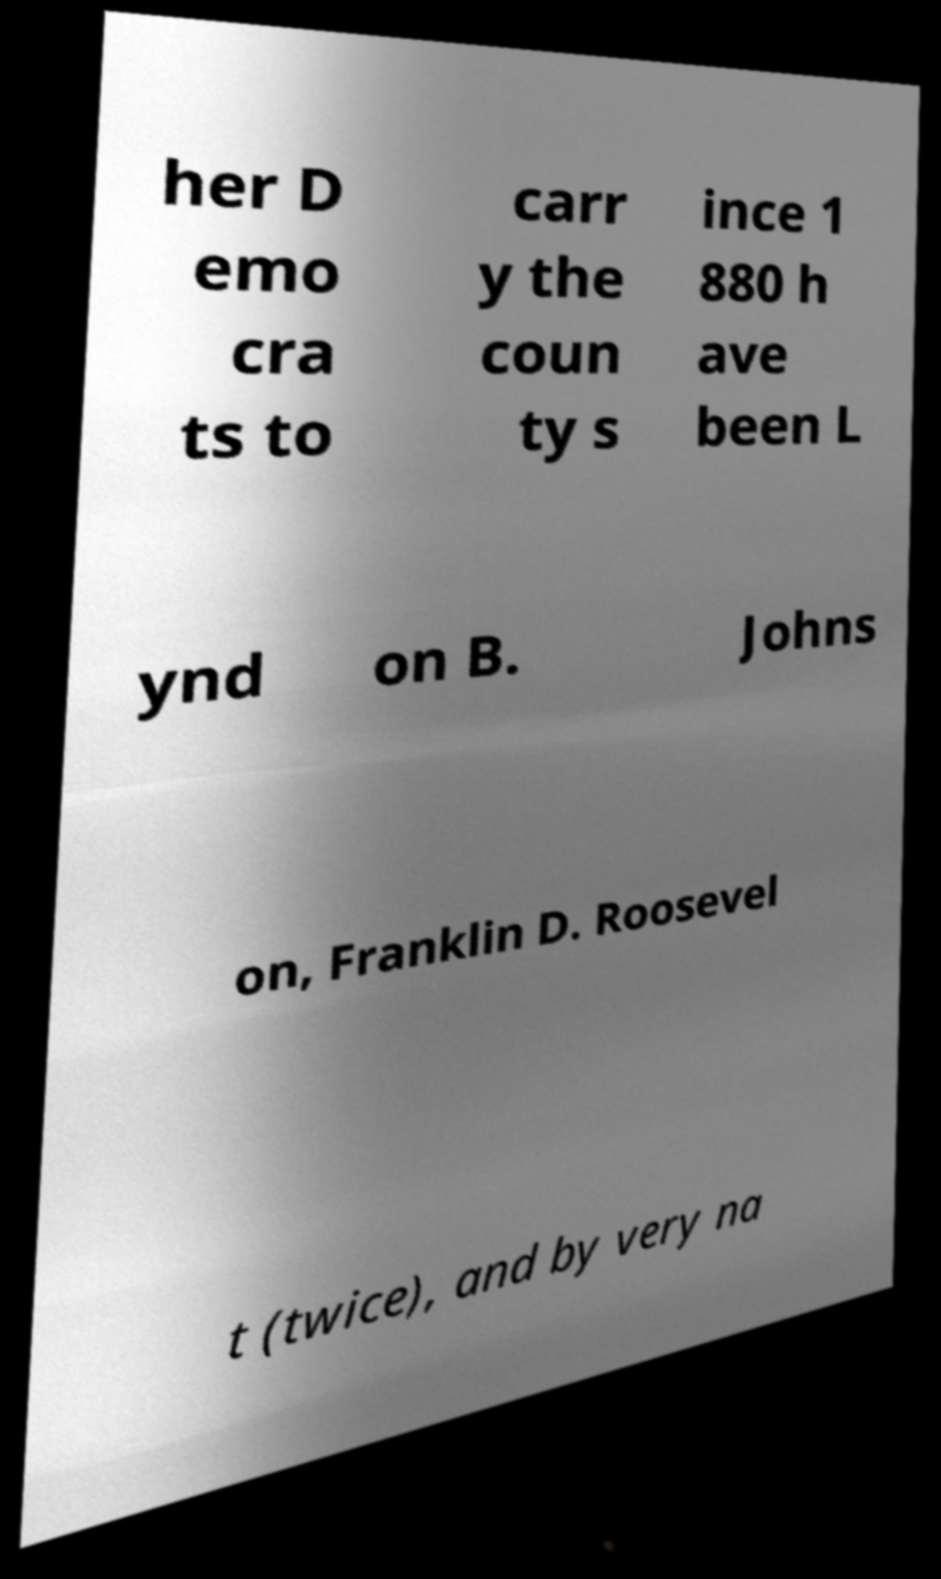Can you accurately transcribe the text from the provided image for me? her D emo cra ts to carr y the coun ty s ince 1 880 h ave been L ynd on B. Johns on, Franklin D. Roosevel t (twice), and by very na 